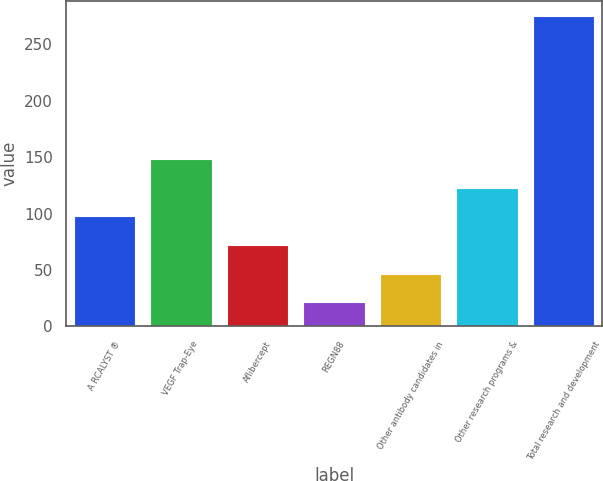Convert chart to OTSL. <chart><loc_0><loc_0><loc_500><loc_500><bar_chart><fcel>A RCALYST ®<fcel>VEGF Trap-Eye<fcel>Aflibercept<fcel>REGN88<fcel>Other antibody candidates in<fcel>Other research programs &<fcel>Total research and development<nl><fcel>97.45<fcel>148.15<fcel>72.1<fcel>21.4<fcel>46.75<fcel>122.8<fcel>274.9<nl></chart> 